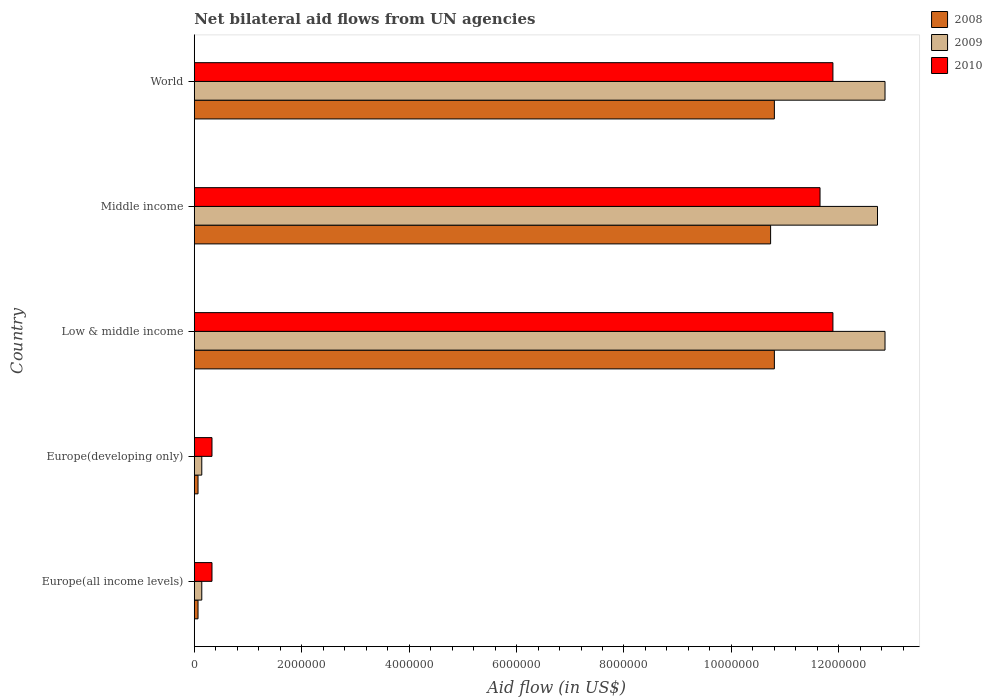Are the number of bars per tick equal to the number of legend labels?
Your answer should be compact. Yes. How many bars are there on the 4th tick from the top?
Your answer should be compact. 3. How many bars are there on the 1st tick from the bottom?
Provide a succinct answer. 3. What is the label of the 5th group of bars from the top?
Provide a short and direct response. Europe(all income levels). In how many cases, is the number of bars for a given country not equal to the number of legend labels?
Keep it short and to the point. 0. Across all countries, what is the maximum net bilateral aid flow in 2010?
Provide a short and direct response. 1.19e+07. Across all countries, what is the minimum net bilateral aid flow in 2008?
Your response must be concise. 7.00e+04. In which country was the net bilateral aid flow in 2010 maximum?
Your answer should be very brief. Low & middle income. In which country was the net bilateral aid flow in 2009 minimum?
Offer a terse response. Europe(all income levels). What is the total net bilateral aid flow in 2010 in the graph?
Provide a succinct answer. 3.61e+07. What is the difference between the net bilateral aid flow in 2010 in Europe(developing only) and the net bilateral aid flow in 2009 in Europe(all income levels)?
Make the answer very short. 1.90e+05. What is the average net bilateral aid flow in 2009 per country?
Provide a succinct answer. 7.74e+06. What is the difference between the net bilateral aid flow in 2008 and net bilateral aid flow in 2009 in Low & middle income?
Offer a very short reply. -2.06e+06. What is the ratio of the net bilateral aid flow in 2009 in Europe(all income levels) to that in World?
Give a very brief answer. 0.01. Is the difference between the net bilateral aid flow in 2008 in Low & middle income and Middle income greater than the difference between the net bilateral aid flow in 2009 in Low & middle income and Middle income?
Make the answer very short. No. What is the difference between the highest and the second highest net bilateral aid flow in 2009?
Offer a very short reply. 0. What is the difference between the highest and the lowest net bilateral aid flow in 2009?
Make the answer very short. 1.27e+07. What does the 2nd bar from the top in Middle income represents?
Your response must be concise. 2009. What does the 1st bar from the bottom in Europe(developing only) represents?
Ensure brevity in your answer.  2008. Is it the case that in every country, the sum of the net bilateral aid flow in 2010 and net bilateral aid flow in 2009 is greater than the net bilateral aid flow in 2008?
Keep it short and to the point. Yes. How many countries are there in the graph?
Your answer should be compact. 5. Does the graph contain grids?
Provide a short and direct response. No. Where does the legend appear in the graph?
Provide a short and direct response. Top right. How are the legend labels stacked?
Ensure brevity in your answer.  Vertical. What is the title of the graph?
Your answer should be very brief. Net bilateral aid flows from UN agencies. What is the label or title of the X-axis?
Provide a short and direct response. Aid flow (in US$). What is the label or title of the Y-axis?
Keep it short and to the point. Country. What is the Aid flow (in US$) in 2009 in Europe(all income levels)?
Ensure brevity in your answer.  1.40e+05. What is the Aid flow (in US$) in 2009 in Europe(developing only)?
Keep it short and to the point. 1.40e+05. What is the Aid flow (in US$) of 2010 in Europe(developing only)?
Provide a succinct answer. 3.30e+05. What is the Aid flow (in US$) in 2008 in Low & middle income?
Ensure brevity in your answer.  1.08e+07. What is the Aid flow (in US$) in 2009 in Low & middle income?
Keep it short and to the point. 1.29e+07. What is the Aid flow (in US$) of 2010 in Low & middle income?
Make the answer very short. 1.19e+07. What is the Aid flow (in US$) of 2008 in Middle income?
Your answer should be compact. 1.07e+07. What is the Aid flow (in US$) in 2009 in Middle income?
Your response must be concise. 1.27e+07. What is the Aid flow (in US$) in 2010 in Middle income?
Give a very brief answer. 1.16e+07. What is the Aid flow (in US$) in 2008 in World?
Provide a succinct answer. 1.08e+07. What is the Aid flow (in US$) in 2009 in World?
Offer a terse response. 1.29e+07. What is the Aid flow (in US$) of 2010 in World?
Provide a short and direct response. 1.19e+07. Across all countries, what is the maximum Aid flow (in US$) of 2008?
Your response must be concise. 1.08e+07. Across all countries, what is the maximum Aid flow (in US$) of 2009?
Offer a very short reply. 1.29e+07. Across all countries, what is the maximum Aid flow (in US$) in 2010?
Provide a short and direct response. 1.19e+07. Across all countries, what is the minimum Aid flow (in US$) in 2010?
Offer a terse response. 3.30e+05. What is the total Aid flow (in US$) in 2008 in the graph?
Your answer should be compact. 3.25e+07. What is the total Aid flow (in US$) in 2009 in the graph?
Your response must be concise. 3.87e+07. What is the total Aid flow (in US$) in 2010 in the graph?
Your response must be concise. 3.61e+07. What is the difference between the Aid flow (in US$) in 2008 in Europe(all income levels) and that in Europe(developing only)?
Offer a very short reply. 0. What is the difference between the Aid flow (in US$) of 2010 in Europe(all income levels) and that in Europe(developing only)?
Offer a terse response. 0. What is the difference between the Aid flow (in US$) in 2008 in Europe(all income levels) and that in Low & middle income?
Your answer should be compact. -1.07e+07. What is the difference between the Aid flow (in US$) in 2009 in Europe(all income levels) and that in Low & middle income?
Offer a very short reply. -1.27e+07. What is the difference between the Aid flow (in US$) of 2010 in Europe(all income levels) and that in Low & middle income?
Offer a terse response. -1.16e+07. What is the difference between the Aid flow (in US$) in 2008 in Europe(all income levels) and that in Middle income?
Provide a short and direct response. -1.07e+07. What is the difference between the Aid flow (in US$) in 2009 in Europe(all income levels) and that in Middle income?
Give a very brief answer. -1.26e+07. What is the difference between the Aid flow (in US$) in 2010 in Europe(all income levels) and that in Middle income?
Your response must be concise. -1.13e+07. What is the difference between the Aid flow (in US$) of 2008 in Europe(all income levels) and that in World?
Give a very brief answer. -1.07e+07. What is the difference between the Aid flow (in US$) in 2009 in Europe(all income levels) and that in World?
Ensure brevity in your answer.  -1.27e+07. What is the difference between the Aid flow (in US$) in 2010 in Europe(all income levels) and that in World?
Your response must be concise. -1.16e+07. What is the difference between the Aid flow (in US$) in 2008 in Europe(developing only) and that in Low & middle income?
Your answer should be very brief. -1.07e+07. What is the difference between the Aid flow (in US$) of 2009 in Europe(developing only) and that in Low & middle income?
Offer a terse response. -1.27e+07. What is the difference between the Aid flow (in US$) in 2010 in Europe(developing only) and that in Low & middle income?
Your answer should be compact. -1.16e+07. What is the difference between the Aid flow (in US$) of 2008 in Europe(developing only) and that in Middle income?
Your answer should be very brief. -1.07e+07. What is the difference between the Aid flow (in US$) of 2009 in Europe(developing only) and that in Middle income?
Provide a short and direct response. -1.26e+07. What is the difference between the Aid flow (in US$) of 2010 in Europe(developing only) and that in Middle income?
Keep it short and to the point. -1.13e+07. What is the difference between the Aid flow (in US$) in 2008 in Europe(developing only) and that in World?
Make the answer very short. -1.07e+07. What is the difference between the Aid flow (in US$) of 2009 in Europe(developing only) and that in World?
Your response must be concise. -1.27e+07. What is the difference between the Aid flow (in US$) of 2010 in Europe(developing only) and that in World?
Offer a very short reply. -1.16e+07. What is the difference between the Aid flow (in US$) of 2008 in Low & middle income and that in Middle income?
Provide a short and direct response. 7.00e+04. What is the difference between the Aid flow (in US$) of 2009 in Low & middle income and that in Middle income?
Offer a terse response. 1.40e+05. What is the difference between the Aid flow (in US$) of 2008 in Low & middle income and that in World?
Offer a very short reply. 0. What is the difference between the Aid flow (in US$) of 2010 in Low & middle income and that in World?
Your answer should be compact. 0. What is the difference between the Aid flow (in US$) in 2008 in Middle income and that in World?
Provide a short and direct response. -7.00e+04. What is the difference between the Aid flow (in US$) of 2010 in Middle income and that in World?
Make the answer very short. -2.40e+05. What is the difference between the Aid flow (in US$) in 2008 in Europe(all income levels) and the Aid flow (in US$) in 2009 in Europe(developing only)?
Keep it short and to the point. -7.00e+04. What is the difference between the Aid flow (in US$) of 2009 in Europe(all income levels) and the Aid flow (in US$) of 2010 in Europe(developing only)?
Offer a very short reply. -1.90e+05. What is the difference between the Aid flow (in US$) in 2008 in Europe(all income levels) and the Aid flow (in US$) in 2009 in Low & middle income?
Provide a succinct answer. -1.28e+07. What is the difference between the Aid flow (in US$) of 2008 in Europe(all income levels) and the Aid flow (in US$) of 2010 in Low & middle income?
Ensure brevity in your answer.  -1.18e+07. What is the difference between the Aid flow (in US$) of 2009 in Europe(all income levels) and the Aid flow (in US$) of 2010 in Low & middle income?
Provide a short and direct response. -1.18e+07. What is the difference between the Aid flow (in US$) of 2008 in Europe(all income levels) and the Aid flow (in US$) of 2009 in Middle income?
Provide a short and direct response. -1.26e+07. What is the difference between the Aid flow (in US$) of 2008 in Europe(all income levels) and the Aid flow (in US$) of 2010 in Middle income?
Offer a very short reply. -1.16e+07. What is the difference between the Aid flow (in US$) in 2009 in Europe(all income levels) and the Aid flow (in US$) in 2010 in Middle income?
Give a very brief answer. -1.15e+07. What is the difference between the Aid flow (in US$) in 2008 in Europe(all income levels) and the Aid flow (in US$) in 2009 in World?
Offer a terse response. -1.28e+07. What is the difference between the Aid flow (in US$) in 2008 in Europe(all income levels) and the Aid flow (in US$) in 2010 in World?
Your answer should be compact. -1.18e+07. What is the difference between the Aid flow (in US$) in 2009 in Europe(all income levels) and the Aid flow (in US$) in 2010 in World?
Offer a very short reply. -1.18e+07. What is the difference between the Aid flow (in US$) in 2008 in Europe(developing only) and the Aid flow (in US$) in 2009 in Low & middle income?
Your answer should be compact. -1.28e+07. What is the difference between the Aid flow (in US$) of 2008 in Europe(developing only) and the Aid flow (in US$) of 2010 in Low & middle income?
Offer a very short reply. -1.18e+07. What is the difference between the Aid flow (in US$) in 2009 in Europe(developing only) and the Aid flow (in US$) in 2010 in Low & middle income?
Give a very brief answer. -1.18e+07. What is the difference between the Aid flow (in US$) in 2008 in Europe(developing only) and the Aid flow (in US$) in 2009 in Middle income?
Keep it short and to the point. -1.26e+07. What is the difference between the Aid flow (in US$) in 2008 in Europe(developing only) and the Aid flow (in US$) in 2010 in Middle income?
Offer a very short reply. -1.16e+07. What is the difference between the Aid flow (in US$) of 2009 in Europe(developing only) and the Aid flow (in US$) of 2010 in Middle income?
Your answer should be compact. -1.15e+07. What is the difference between the Aid flow (in US$) in 2008 in Europe(developing only) and the Aid flow (in US$) in 2009 in World?
Your answer should be very brief. -1.28e+07. What is the difference between the Aid flow (in US$) in 2008 in Europe(developing only) and the Aid flow (in US$) in 2010 in World?
Provide a short and direct response. -1.18e+07. What is the difference between the Aid flow (in US$) of 2009 in Europe(developing only) and the Aid flow (in US$) of 2010 in World?
Your answer should be compact. -1.18e+07. What is the difference between the Aid flow (in US$) of 2008 in Low & middle income and the Aid flow (in US$) of 2009 in Middle income?
Give a very brief answer. -1.92e+06. What is the difference between the Aid flow (in US$) in 2008 in Low & middle income and the Aid flow (in US$) in 2010 in Middle income?
Make the answer very short. -8.50e+05. What is the difference between the Aid flow (in US$) of 2009 in Low & middle income and the Aid flow (in US$) of 2010 in Middle income?
Give a very brief answer. 1.21e+06. What is the difference between the Aid flow (in US$) in 2008 in Low & middle income and the Aid flow (in US$) in 2009 in World?
Your response must be concise. -2.06e+06. What is the difference between the Aid flow (in US$) of 2008 in Low & middle income and the Aid flow (in US$) of 2010 in World?
Your answer should be compact. -1.09e+06. What is the difference between the Aid flow (in US$) in 2009 in Low & middle income and the Aid flow (in US$) in 2010 in World?
Offer a terse response. 9.70e+05. What is the difference between the Aid flow (in US$) in 2008 in Middle income and the Aid flow (in US$) in 2009 in World?
Keep it short and to the point. -2.13e+06. What is the difference between the Aid flow (in US$) in 2008 in Middle income and the Aid flow (in US$) in 2010 in World?
Your answer should be very brief. -1.16e+06. What is the difference between the Aid flow (in US$) in 2009 in Middle income and the Aid flow (in US$) in 2010 in World?
Offer a terse response. 8.30e+05. What is the average Aid flow (in US$) of 2008 per country?
Ensure brevity in your answer.  6.49e+06. What is the average Aid flow (in US$) in 2009 per country?
Make the answer very short. 7.74e+06. What is the average Aid flow (in US$) in 2010 per country?
Provide a short and direct response. 7.22e+06. What is the difference between the Aid flow (in US$) of 2008 and Aid flow (in US$) of 2009 in Europe(all income levels)?
Offer a terse response. -7.00e+04. What is the difference between the Aid flow (in US$) in 2009 and Aid flow (in US$) in 2010 in Europe(all income levels)?
Your response must be concise. -1.90e+05. What is the difference between the Aid flow (in US$) of 2009 and Aid flow (in US$) of 2010 in Europe(developing only)?
Offer a very short reply. -1.90e+05. What is the difference between the Aid flow (in US$) of 2008 and Aid flow (in US$) of 2009 in Low & middle income?
Keep it short and to the point. -2.06e+06. What is the difference between the Aid flow (in US$) of 2008 and Aid flow (in US$) of 2010 in Low & middle income?
Keep it short and to the point. -1.09e+06. What is the difference between the Aid flow (in US$) in 2009 and Aid flow (in US$) in 2010 in Low & middle income?
Offer a terse response. 9.70e+05. What is the difference between the Aid flow (in US$) of 2008 and Aid flow (in US$) of 2009 in Middle income?
Your answer should be compact. -1.99e+06. What is the difference between the Aid flow (in US$) of 2008 and Aid flow (in US$) of 2010 in Middle income?
Ensure brevity in your answer.  -9.20e+05. What is the difference between the Aid flow (in US$) in 2009 and Aid flow (in US$) in 2010 in Middle income?
Your answer should be compact. 1.07e+06. What is the difference between the Aid flow (in US$) of 2008 and Aid flow (in US$) of 2009 in World?
Ensure brevity in your answer.  -2.06e+06. What is the difference between the Aid flow (in US$) of 2008 and Aid flow (in US$) of 2010 in World?
Provide a short and direct response. -1.09e+06. What is the difference between the Aid flow (in US$) of 2009 and Aid flow (in US$) of 2010 in World?
Ensure brevity in your answer.  9.70e+05. What is the ratio of the Aid flow (in US$) in 2008 in Europe(all income levels) to that in Low & middle income?
Your answer should be compact. 0.01. What is the ratio of the Aid flow (in US$) of 2009 in Europe(all income levels) to that in Low & middle income?
Give a very brief answer. 0.01. What is the ratio of the Aid flow (in US$) in 2010 in Europe(all income levels) to that in Low & middle income?
Offer a terse response. 0.03. What is the ratio of the Aid flow (in US$) in 2008 in Europe(all income levels) to that in Middle income?
Provide a succinct answer. 0.01. What is the ratio of the Aid flow (in US$) of 2009 in Europe(all income levels) to that in Middle income?
Offer a very short reply. 0.01. What is the ratio of the Aid flow (in US$) of 2010 in Europe(all income levels) to that in Middle income?
Ensure brevity in your answer.  0.03. What is the ratio of the Aid flow (in US$) of 2008 in Europe(all income levels) to that in World?
Offer a very short reply. 0.01. What is the ratio of the Aid flow (in US$) in 2009 in Europe(all income levels) to that in World?
Make the answer very short. 0.01. What is the ratio of the Aid flow (in US$) in 2010 in Europe(all income levels) to that in World?
Your answer should be compact. 0.03. What is the ratio of the Aid flow (in US$) of 2008 in Europe(developing only) to that in Low & middle income?
Provide a short and direct response. 0.01. What is the ratio of the Aid flow (in US$) in 2009 in Europe(developing only) to that in Low & middle income?
Offer a very short reply. 0.01. What is the ratio of the Aid flow (in US$) in 2010 in Europe(developing only) to that in Low & middle income?
Your answer should be compact. 0.03. What is the ratio of the Aid flow (in US$) in 2008 in Europe(developing only) to that in Middle income?
Keep it short and to the point. 0.01. What is the ratio of the Aid flow (in US$) of 2009 in Europe(developing only) to that in Middle income?
Provide a succinct answer. 0.01. What is the ratio of the Aid flow (in US$) of 2010 in Europe(developing only) to that in Middle income?
Ensure brevity in your answer.  0.03. What is the ratio of the Aid flow (in US$) of 2008 in Europe(developing only) to that in World?
Ensure brevity in your answer.  0.01. What is the ratio of the Aid flow (in US$) in 2009 in Europe(developing only) to that in World?
Your answer should be compact. 0.01. What is the ratio of the Aid flow (in US$) of 2010 in Europe(developing only) to that in World?
Offer a very short reply. 0.03. What is the ratio of the Aid flow (in US$) of 2010 in Low & middle income to that in Middle income?
Your answer should be compact. 1.02. What is the ratio of the Aid flow (in US$) of 2008 in Low & middle income to that in World?
Provide a short and direct response. 1. What is the ratio of the Aid flow (in US$) of 2009 in Low & middle income to that in World?
Provide a succinct answer. 1. What is the ratio of the Aid flow (in US$) in 2010 in Low & middle income to that in World?
Keep it short and to the point. 1. What is the ratio of the Aid flow (in US$) of 2008 in Middle income to that in World?
Keep it short and to the point. 0.99. What is the ratio of the Aid flow (in US$) of 2010 in Middle income to that in World?
Your answer should be very brief. 0.98. What is the difference between the highest and the second highest Aid flow (in US$) in 2008?
Your answer should be very brief. 0. What is the difference between the highest and the second highest Aid flow (in US$) of 2009?
Make the answer very short. 0. What is the difference between the highest and the second highest Aid flow (in US$) in 2010?
Give a very brief answer. 0. What is the difference between the highest and the lowest Aid flow (in US$) of 2008?
Your answer should be very brief. 1.07e+07. What is the difference between the highest and the lowest Aid flow (in US$) in 2009?
Offer a terse response. 1.27e+07. What is the difference between the highest and the lowest Aid flow (in US$) in 2010?
Provide a succinct answer. 1.16e+07. 